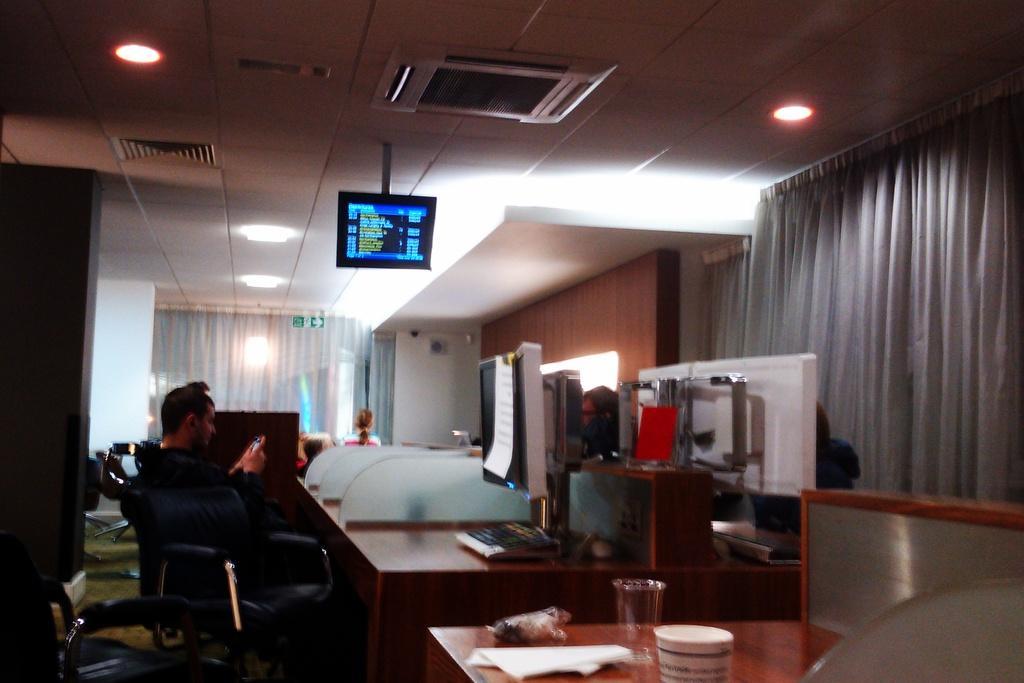Please provide a concise description of this image. In this image we can see inside view of a building. We can see a person sitting on a chair. Beside the person we can see a group of objects on a surface. At the bottom we can see few objects on the table. On the right side, we can see a curtain. At the top we can see a roof, screen, AC vents and lights. Behind the person we can see a curtain and wall. On the left side we can see a pillar. 